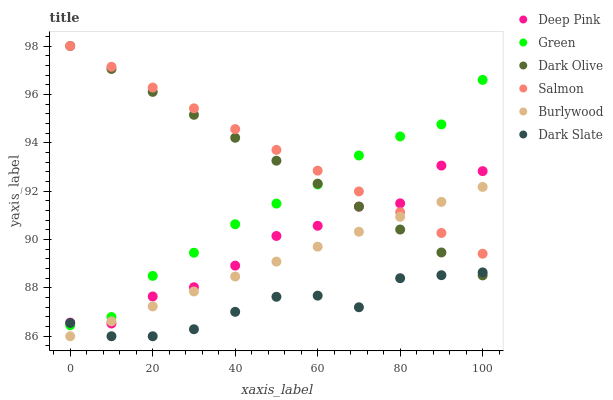Does Dark Slate have the minimum area under the curve?
Answer yes or no. Yes. Does Salmon have the maximum area under the curve?
Answer yes or no. Yes. Does Burlywood have the minimum area under the curve?
Answer yes or no. No. Does Burlywood have the maximum area under the curve?
Answer yes or no. No. Is Burlywood the smoothest?
Answer yes or no. Yes. Is Deep Pink the roughest?
Answer yes or no. Yes. Is Dark Olive the smoothest?
Answer yes or no. No. Is Dark Olive the roughest?
Answer yes or no. No. Does Burlywood have the lowest value?
Answer yes or no. Yes. Does Dark Olive have the lowest value?
Answer yes or no. No. Does Salmon have the highest value?
Answer yes or no. Yes. Does Burlywood have the highest value?
Answer yes or no. No. Is Dark Slate less than Deep Pink?
Answer yes or no. Yes. Is Deep Pink greater than Dark Slate?
Answer yes or no. Yes. Does Dark Slate intersect Dark Olive?
Answer yes or no. Yes. Is Dark Slate less than Dark Olive?
Answer yes or no. No. Is Dark Slate greater than Dark Olive?
Answer yes or no. No. Does Dark Slate intersect Deep Pink?
Answer yes or no. No. 